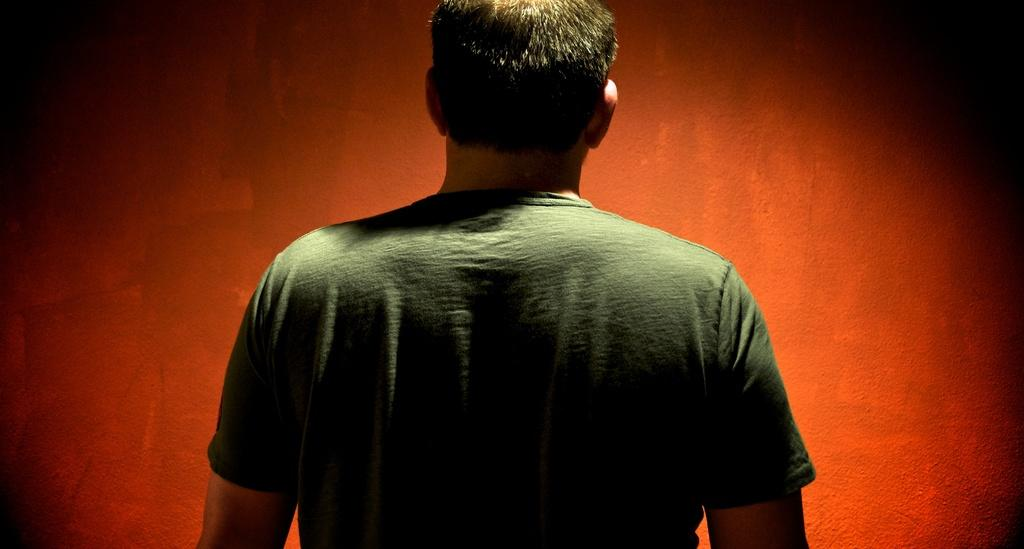Who is the main subject in the picture? There is a man in the picture. Where is the man located in the image? The man is in the middle of the picture. What is the man wearing in the image? The man is wearing a green color T-shirt. What is the color of the background in the image? The background of the image is in red color. Can you tell me how many fish are swimming in the red background of the image? There are no fish present in the image; the background is in red color, and the main subject is a man wearing a green T-shirt. 